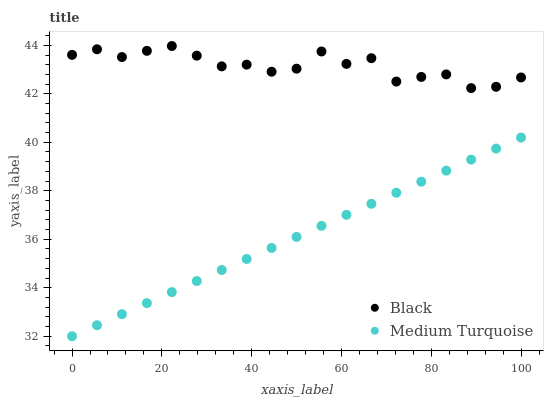Does Medium Turquoise have the minimum area under the curve?
Answer yes or no. Yes. Does Black have the maximum area under the curve?
Answer yes or no. Yes. Does Medium Turquoise have the maximum area under the curve?
Answer yes or no. No. Is Medium Turquoise the smoothest?
Answer yes or no. Yes. Is Black the roughest?
Answer yes or no. Yes. Is Medium Turquoise the roughest?
Answer yes or no. No. Does Medium Turquoise have the lowest value?
Answer yes or no. Yes. Does Black have the highest value?
Answer yes or no. Yes. Does Medium Turquoise have the highest value?
Answer yes or no. No. Is Medium Turquoise less than Black?
Answer yes or no. Yes. Is Black greater than Medium Turquoise?
Answer yes or no. Yes. Does Medium Turquoise intersect Black?
Answer yes or no. No. 